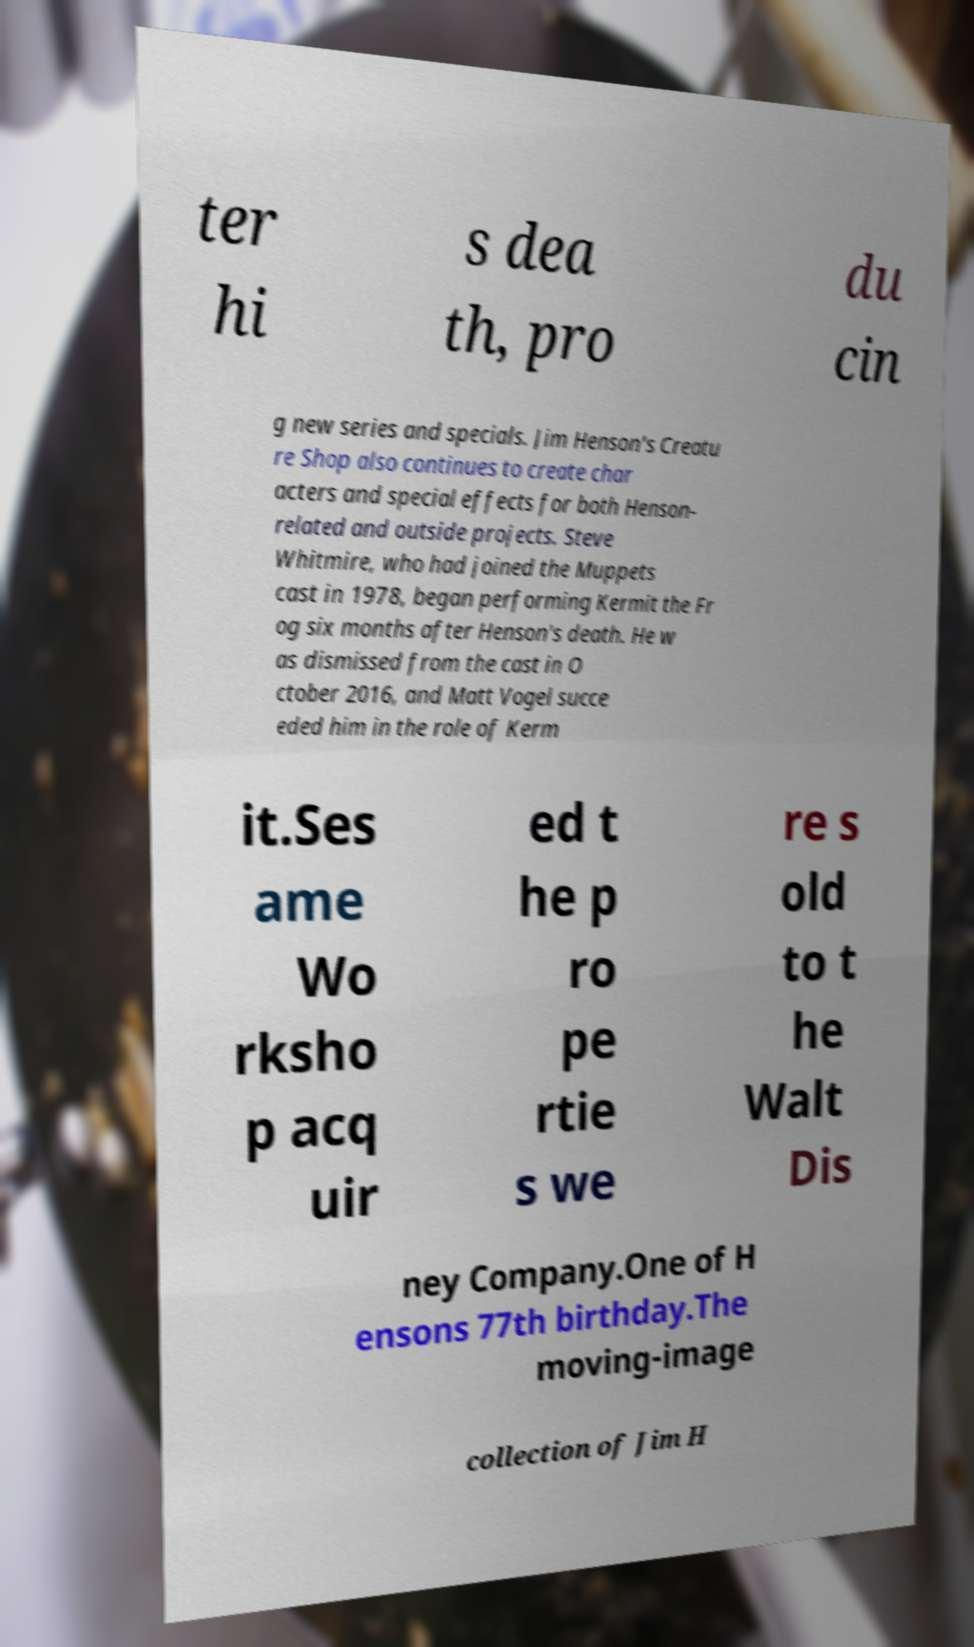Please read and relay the text visible in this image. What does it say? ter hi s dea th, pro du cin g new series and specials. Jim Henson's Creatu re Shop also continues to create char acters and special effects for both Henson- related and outside projects. Steve Whitmire, who had joined the Muppets cast in 1978, began performing Kermit the Fr og six months after Henson's death. He w as dismissed from the cast in O ctober 2016, and Matt Vogel succe eded him in the role of Kerm it.Ses ame Wo rksho p acq uir ed t he p ro pe rtie s we re s old to t he Walt Dis ney Company.One of H ensons 77th birthday.The moving-image collection of Jim H 